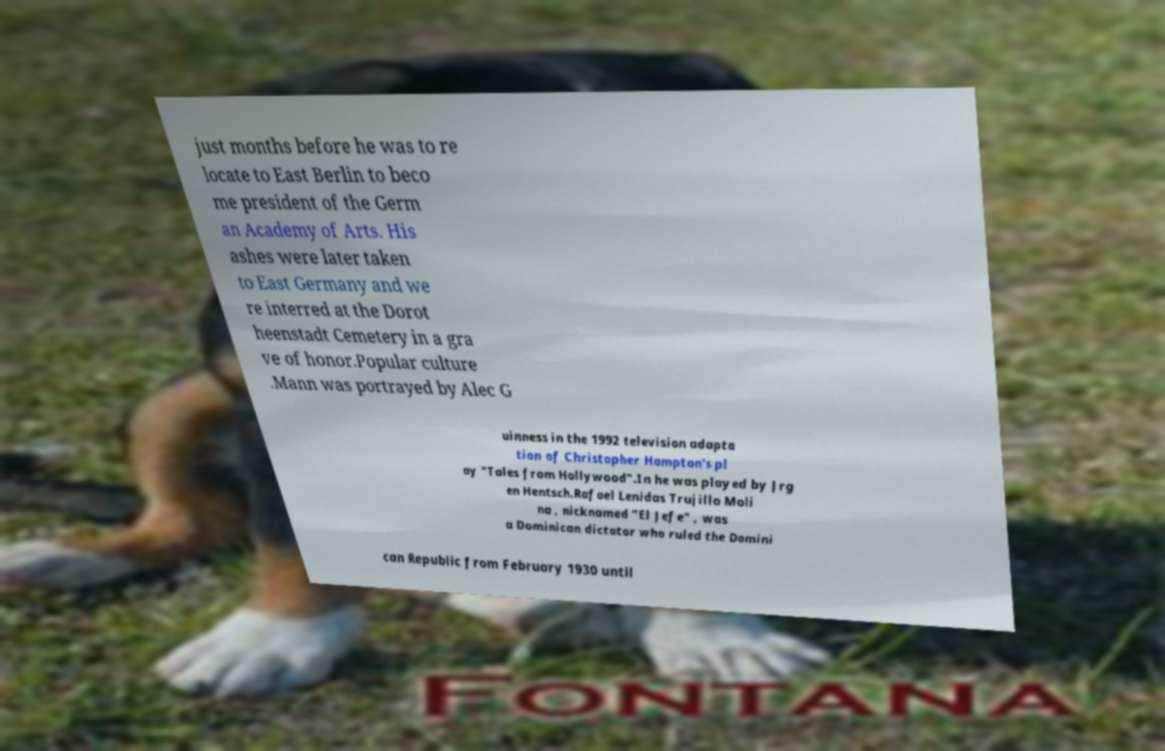I need the written content from this picture converted into text. Can you do that? just months before he was to re locate to East Berlin to beco me president of the Germ an Academy of Arts. His ashes were later taken to East Germany and we re interred at the Dorot heenstadt Cemetery in a gra ve of honor.Popular culture .Mann was portrayed by Alec G uinness in the 1992 television adapta tion of Christopher Hampton's pl ay "Tales from Hollywood".In he was played by Jrg en Hentsch.Rafael Lenidas Trujillo Moli na , nicknamed "El Jefe" , was a Dominican dictator who ruled the Domini can Republic from February 1930 until 